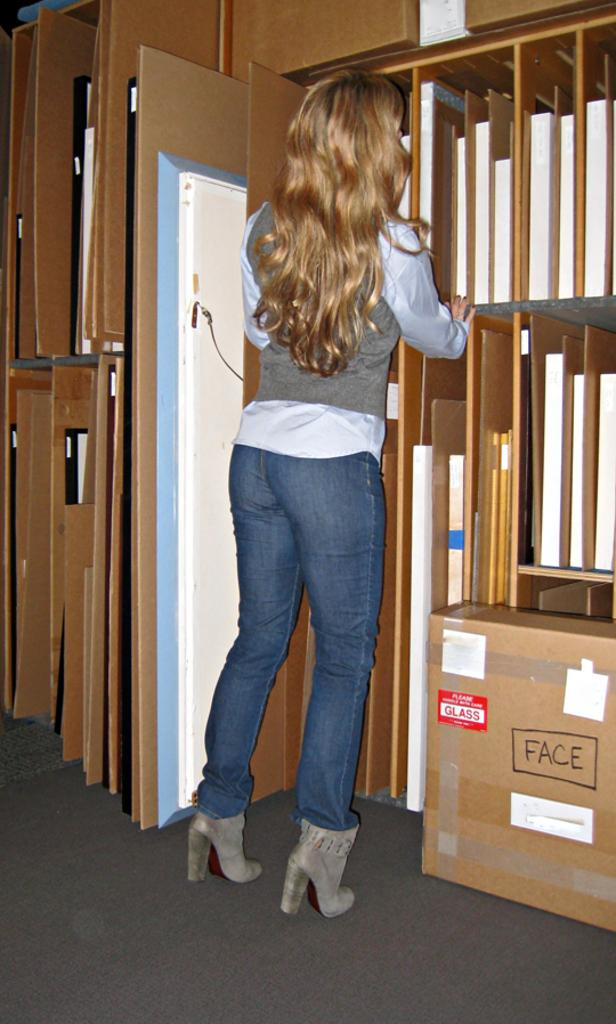Provide a one-sentence caption for the provided image. The box labeled with "Face" contains glass items. 